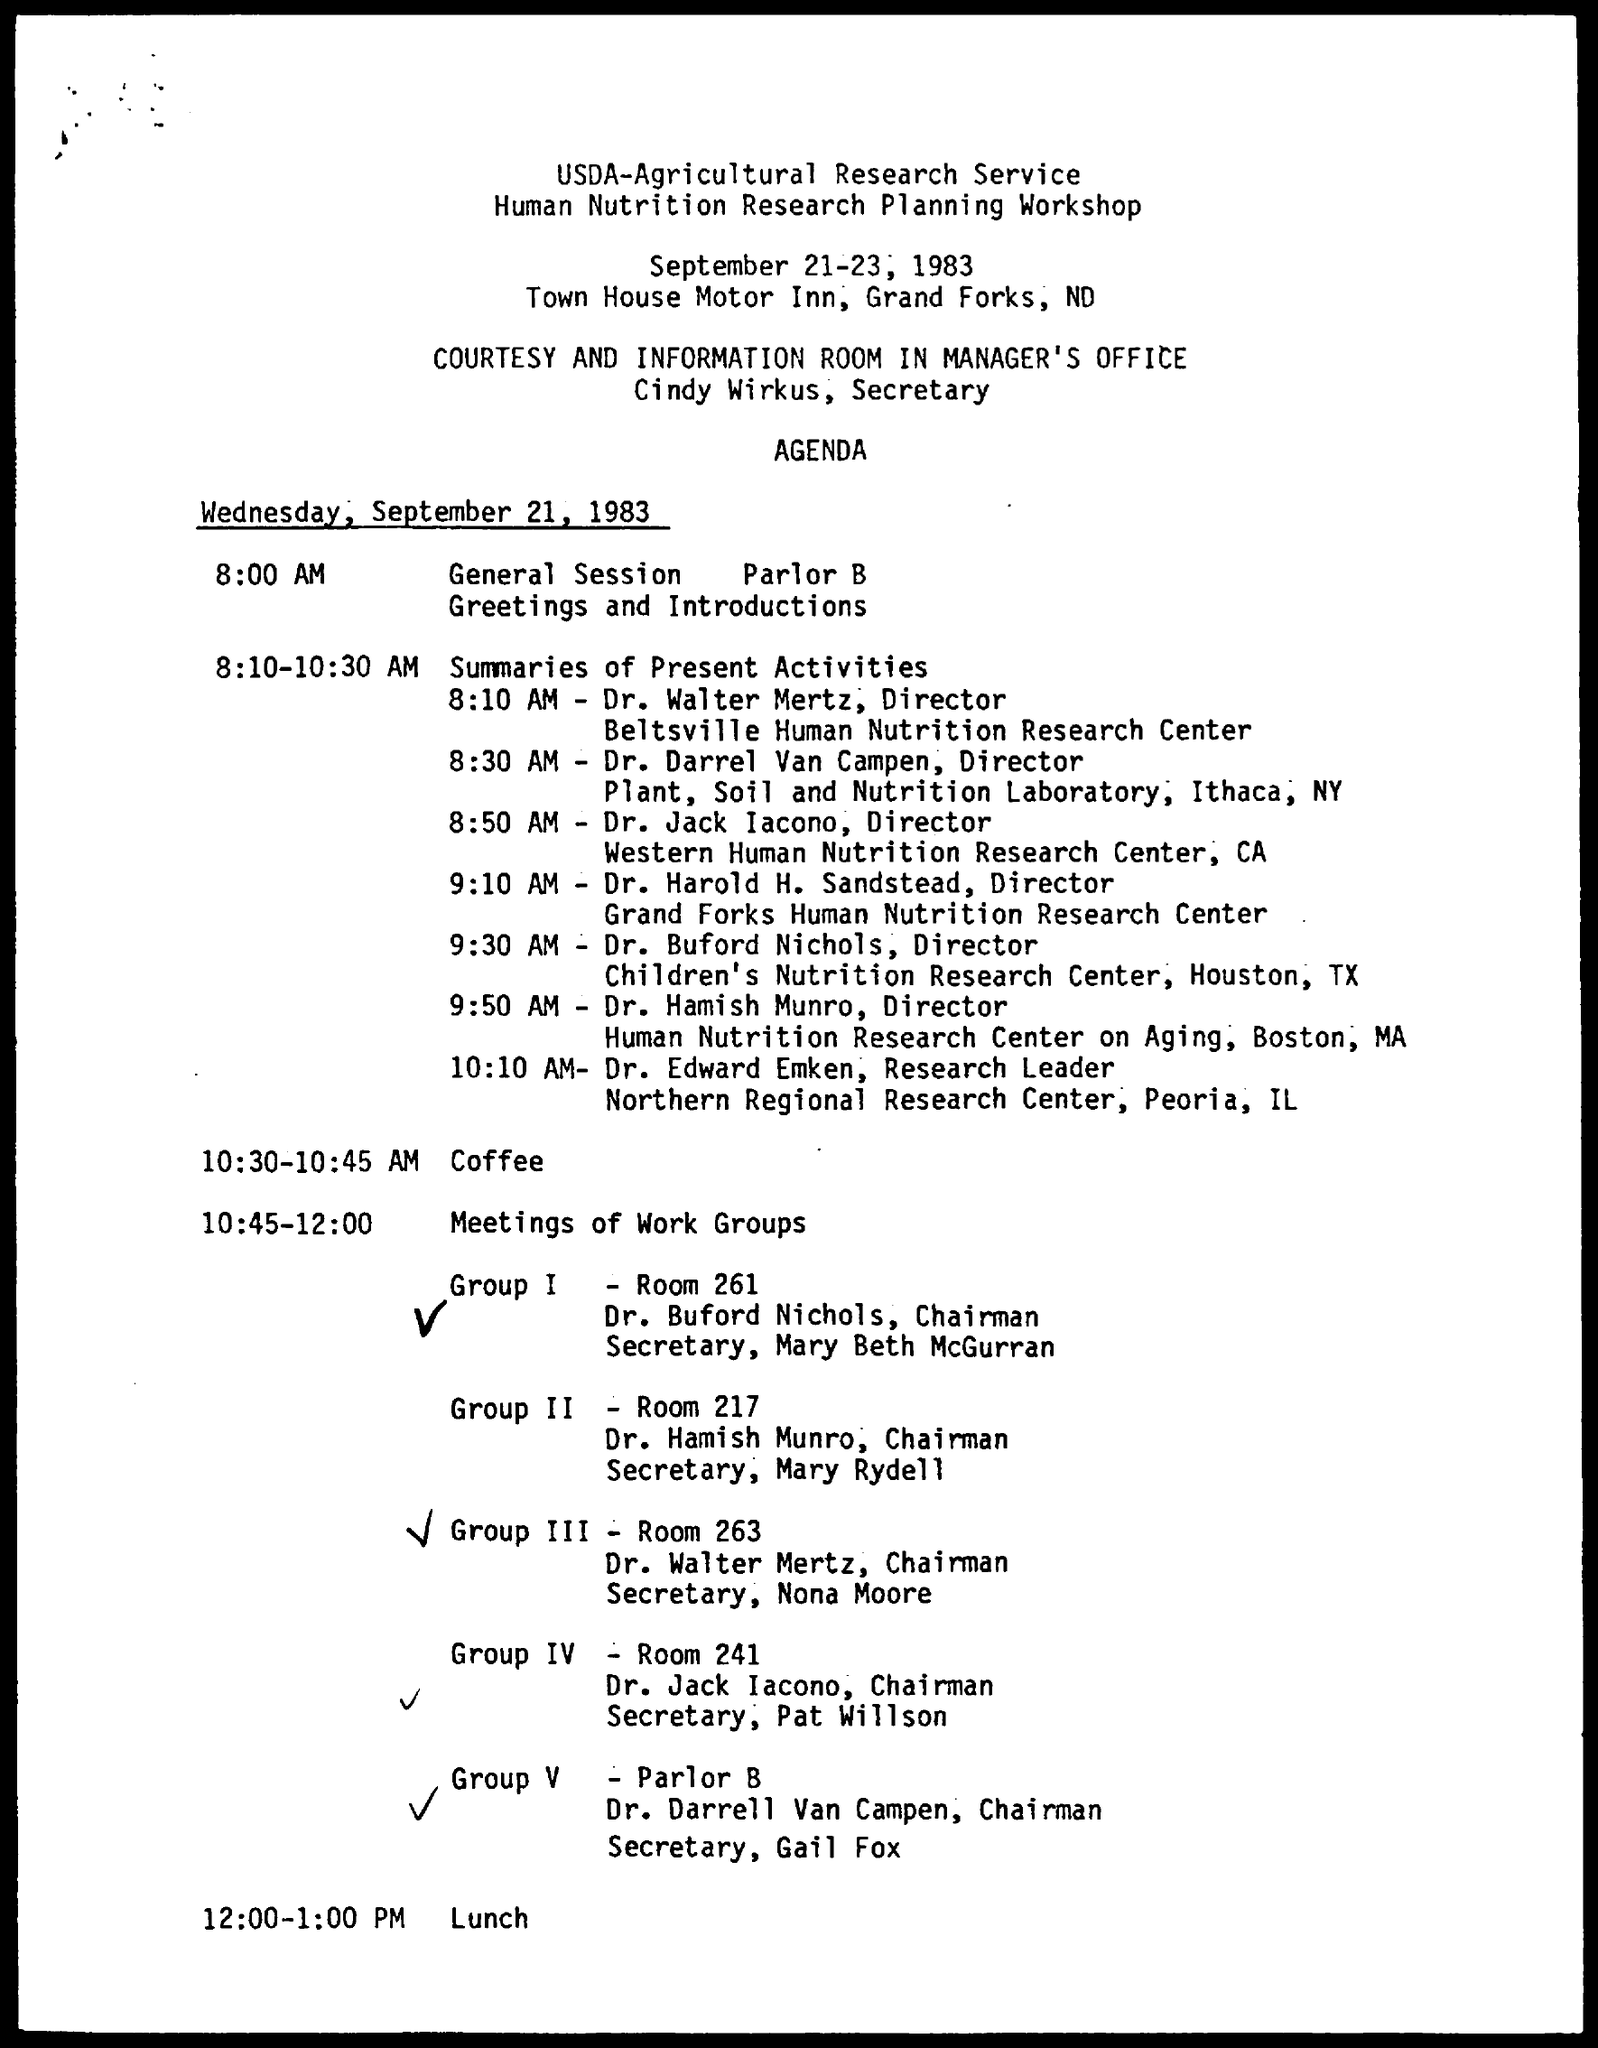What is the designation of dr. walter mertz ?
Offer a terse response. Director. What is the designation of dr. darrel van campen ?
Offer a terse response. Director. What is the designation of dr. edward emken ?
Make the answer very short. Research Leader. What is the given schedule during 10:30-10:45 am mentioned in the given agenda ?
Your answer should be very brief. Coffee. What is the schedule at the time 2:00 - 1:00 pm as mentioned in the given agenda ?
Provide a succinct answer. Lunch. 